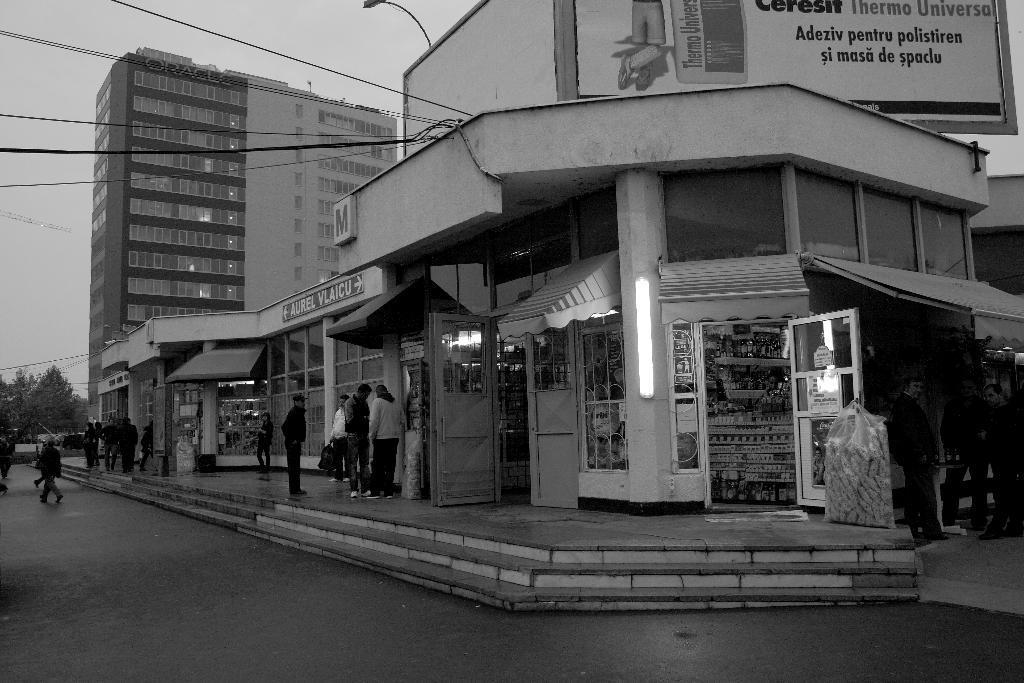How would you summarize this image in a sentence or two? This is completely an outdoor picture and it is a black and white picture. On the background of the picture we can see sky and a huge building. Beside to the building there are trees. Near to the building these are the stores. We can see few persons standings nearer to the stores. This is the road. We can see people walking on the road. This is the light near to the store. 